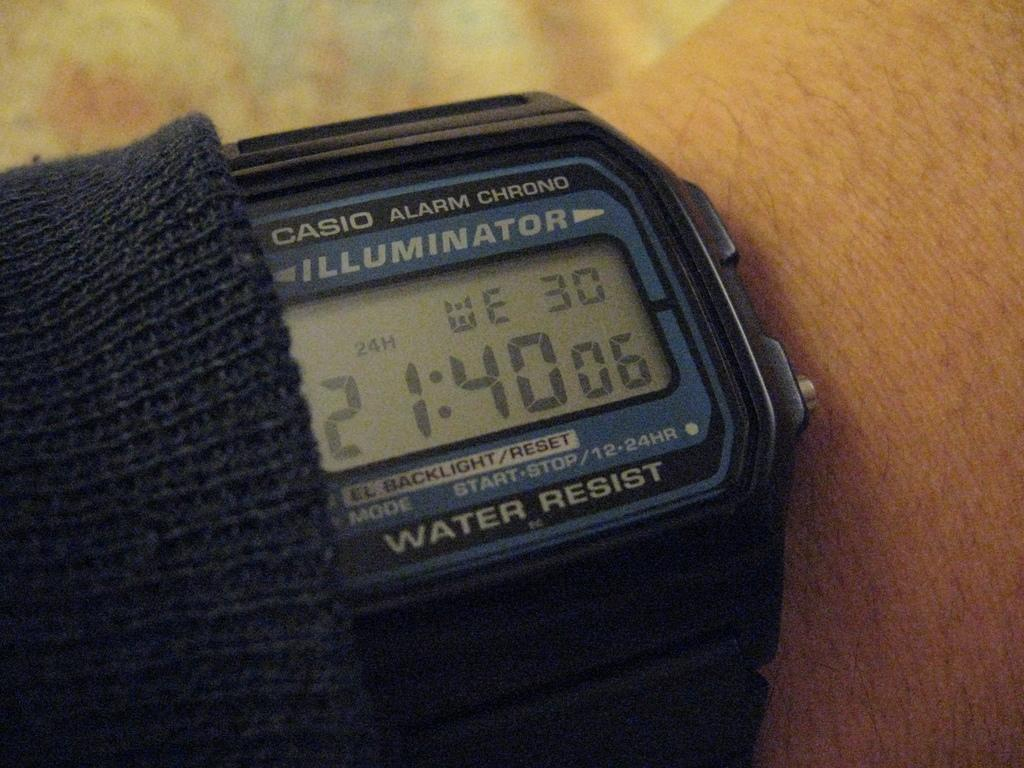<image>
Create a compact narrative representing the image presented. A digital Casio Alarm Chrono Illuminator watch that is water resistant. 